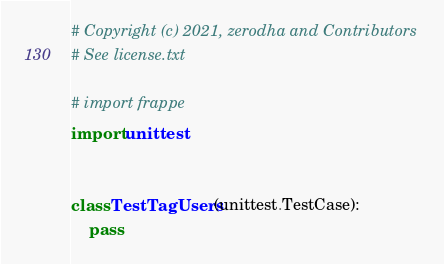Convert code to text. <code><loc_0><loc_0><loc_500><loc_500><_Python_># Copyright (c) 2021, zerodha and Contributors
# See license.txt

# import frappe
import unittest


class TestTagUsers(unittest.TestCase):
    pass
</code> 